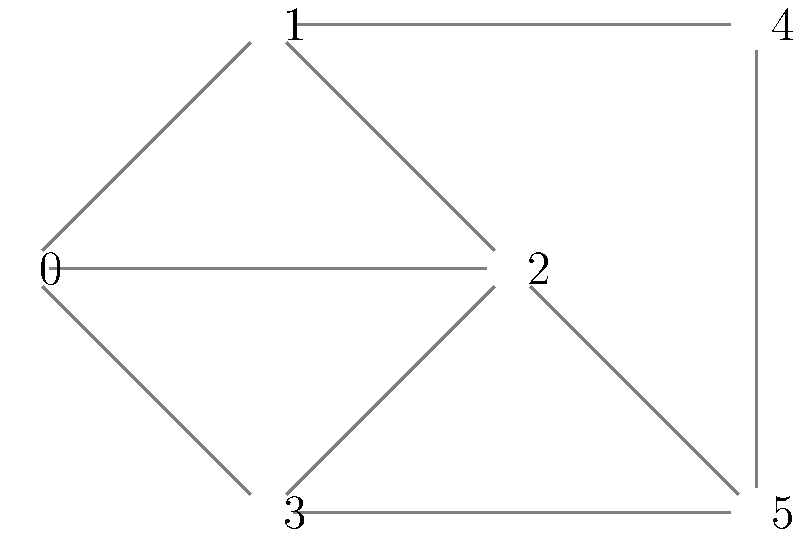In the context of optimizing color palette selection for a digital art tool, consider the graph above representing color relationships. Each vertex represents a color, and edges connect colors that should not be adjacent in the palette. What is the minimum number of distinct colors (chromatic number) needed to color this graph such that no two adjacent vertices have the same color? To determine the chromatic number of this graph, we'll use a step-by-step approach:

1. Analyze the graph structure:
   - The graph has 6 vertices (0 to 5)
   - It contains multiple triangles and a central vertex (2) connected to many others

2. Start coloring from the most connected vertex:
   - Vertex 2 has the highest degree (5 connections)
   - Assign color 1 to vertex 2

3. Color the neighbors of vertex 2:
   - Vertices 0, 1, 3, and 5 are all connected to 2
   - They must all have different colors from 2 and each other
   - Assign colors 2, 3, 4, and 5 to these vertices

4. Color the remaining vertex:
   - Vertex 4 is connected to 1 and 5
   - It can't use colors 3 or 5
   - We can assign color 2 to vertex 4 (same as vertex 0)

5. Verify the coloring:
   - No adjacent vertices have the same color
   - We used a total of 5 colors

6. Check if we can reduce the number of colors:
   - The graph contains a 5-clique (subgraph where all vertices are connected)
   - This 5-clique requires at least 5 colors
   - Therefore, 5 is the minimum number of colors needed

The chromatic number of this graph is 5, meaning we need at least 5 distinct colors in our palette to satisfy the given color relationship constraints.
Answer: 5 